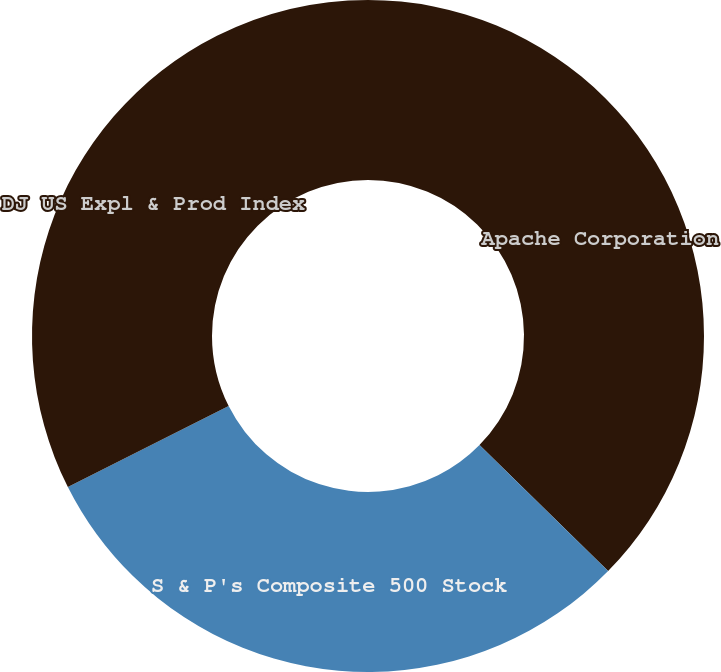Convert chart. <chart><loc_0><loc_0><loc_500><loc_500><pie_chart><fcel>Apache Corporation<fcel>S & P's Composite 500 Stock<fcel>DJ US Expl & Prod Index<nl><fcel>37.33%<fcel>30.25%<fcel>32.42%<nl></chart> 